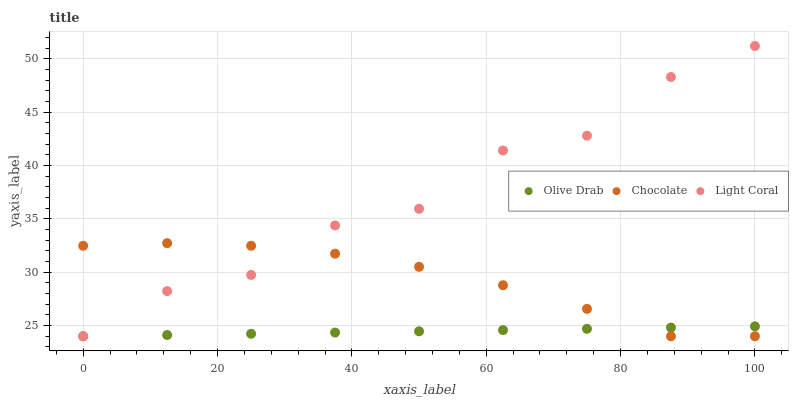Does Olive Drab have the minimum area under the curve?
Answer yes or no. Yes. Does Light Coral have the maximum area under the curve?
Answer yes or no. Yes. Does Chocolate have the minimum area under the curve?
Answer yes or no. No. Does Chocolate have the maximum area under the curve?
Answer yes or no. No. Is Olive Drab the smoothest?
Answer yes or no. Yes. Is Light Coral the roughest?
Answer yes or no. Yes. Is Chocolate the smoothest?
Answer yes or no. No. Is Chocolate the roughest?
Answer yes or no. No. Does Light Coral have the lowest value?
Answer yes or no. Yes. Does Light Coral have the highest value?
Answer yes or no. Yes. Does Chocolate have the highest value?
Answer yes or no. No. Does Olive Drab intersect Chocolate?
Answer yes or no. Yes. Is Olive Drab less than Chocolate?
Answer yes or no. No. Is Olive Drab greater than Chocolate?
Answer yes or no. No. 